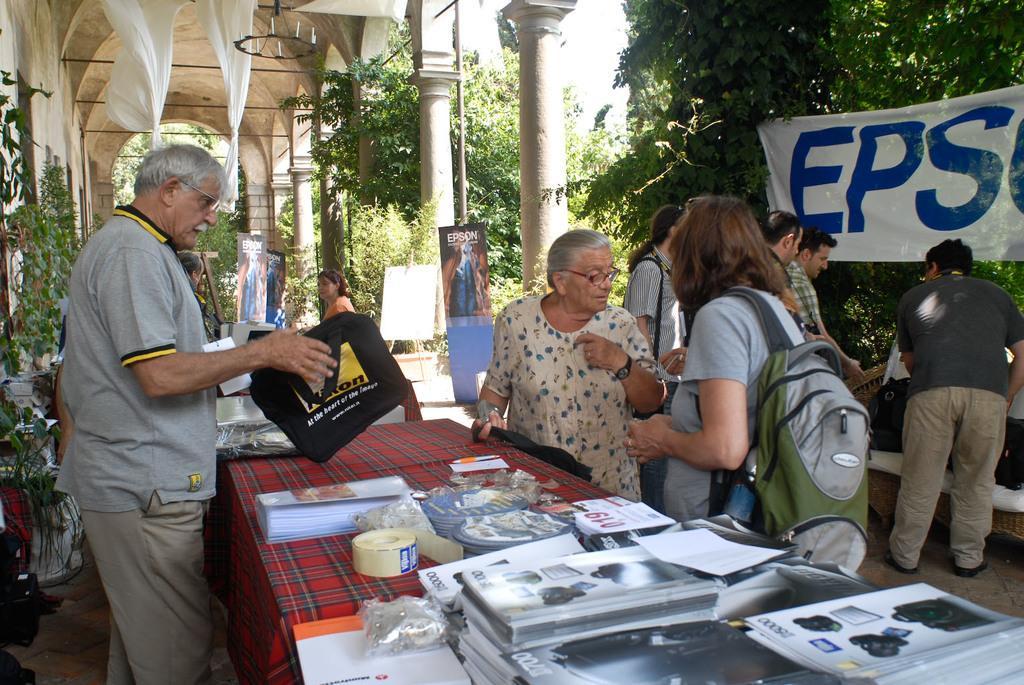Please provide a concise description of this image. In this image, In the middle there is a table which is covered by a red cloth and there are some people standing and in the right side there are some green color trees and there are some walls which are in white color. 